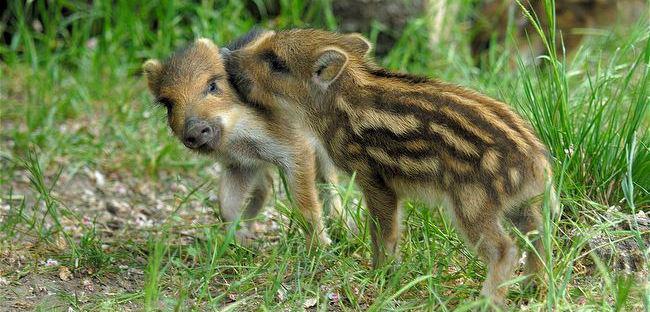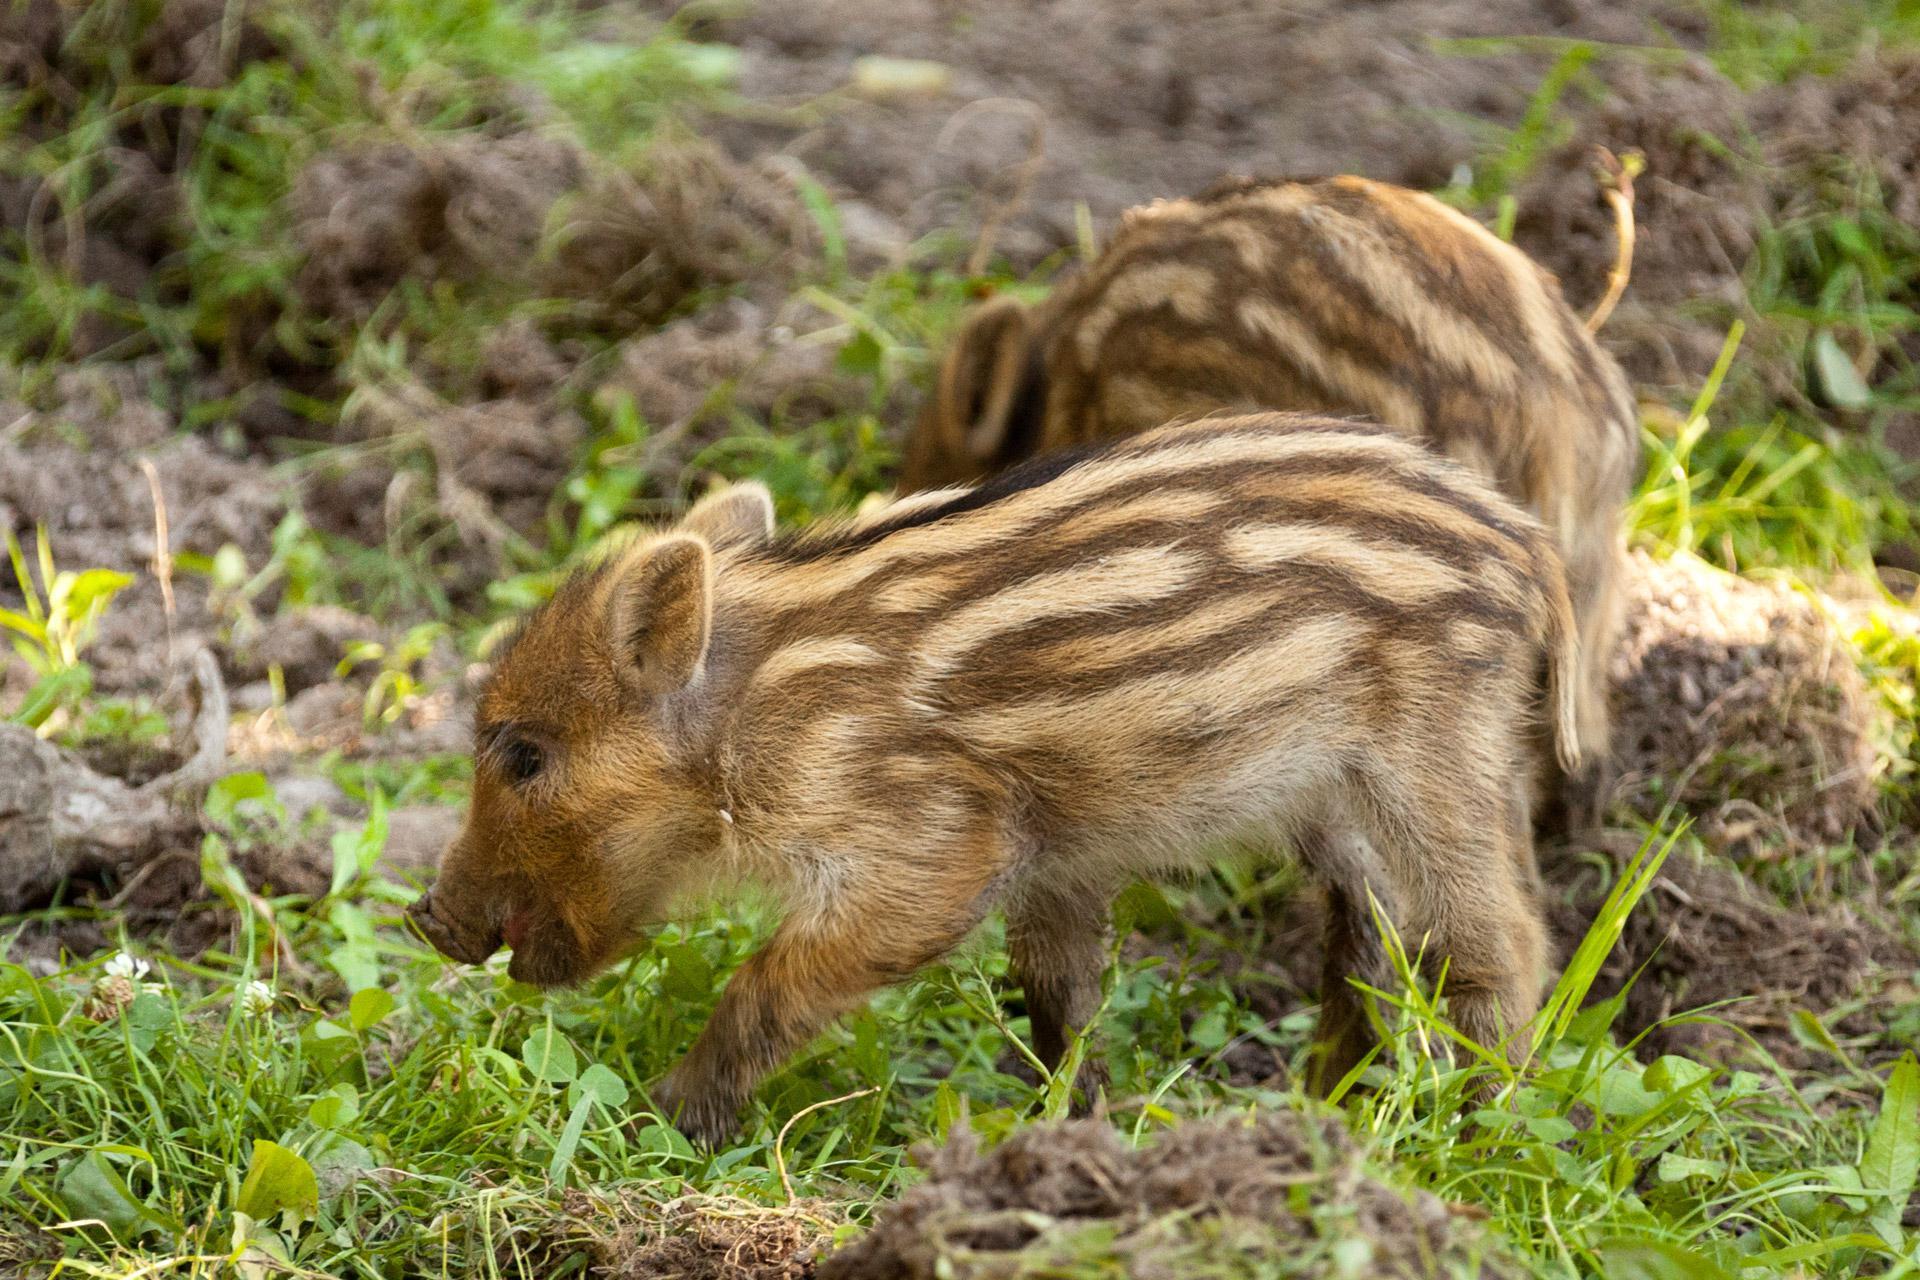The first image is the image on the left, the second image is the image on the right. Considering the images on both sides, is "Both images show the same number of baby warthogs." valid? Answer yes or no. Yes. The first image is the image on the left, the second image is the image on the right. Given the left and right images, does the statement "Each image includes at least one piglet with distinctive beige and brown stripes standing in profile on all fours." hold true? Answer yes or no. Yes. 